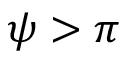Convert formula to latex. <formula><loc_0><loc_0><loc_500><loc_500>\psi > \pi</formula> 